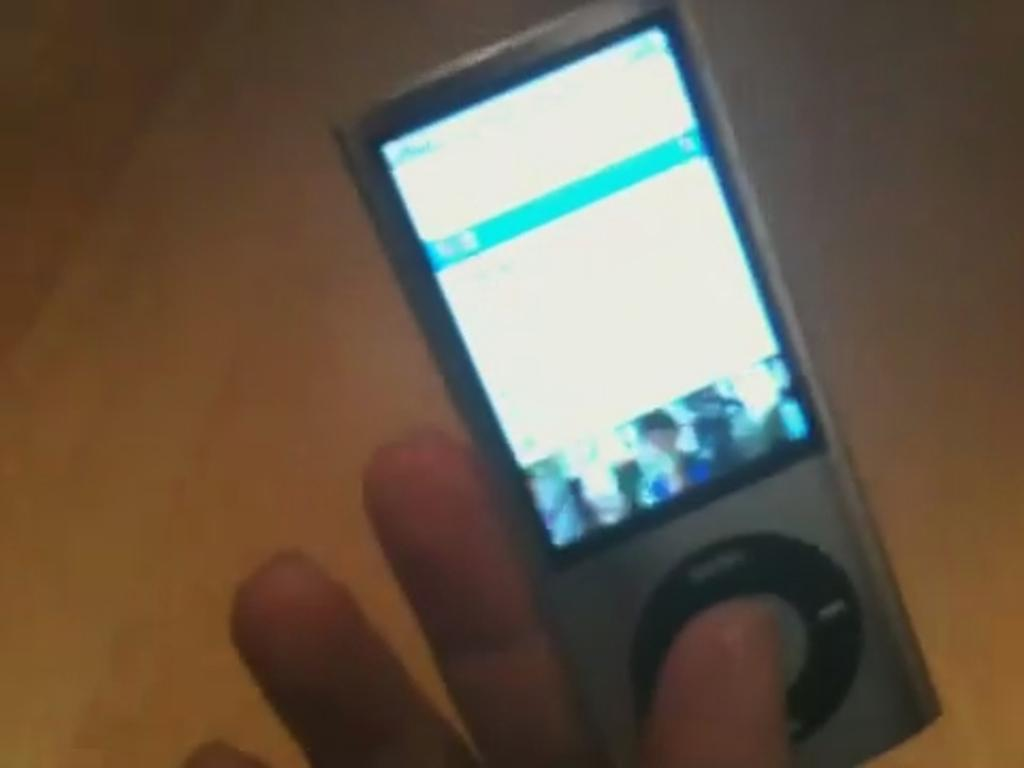What part of a person can be seen in the image? There is a person's hand in the image. What object is present in the image along with the hand? There is a device in the image. What type of garden can be seen in the image? There is no garden present in the image; it only features a person's hand and a device. Is there a gun visible in the image? No, there is no gun present in the image. 